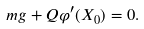<formula> <loc_0><loc_0><loc_500><loc_500>m g + Q \varphi ^ { \prime } ( X _ { 0 } ) = 0 .</formula> 